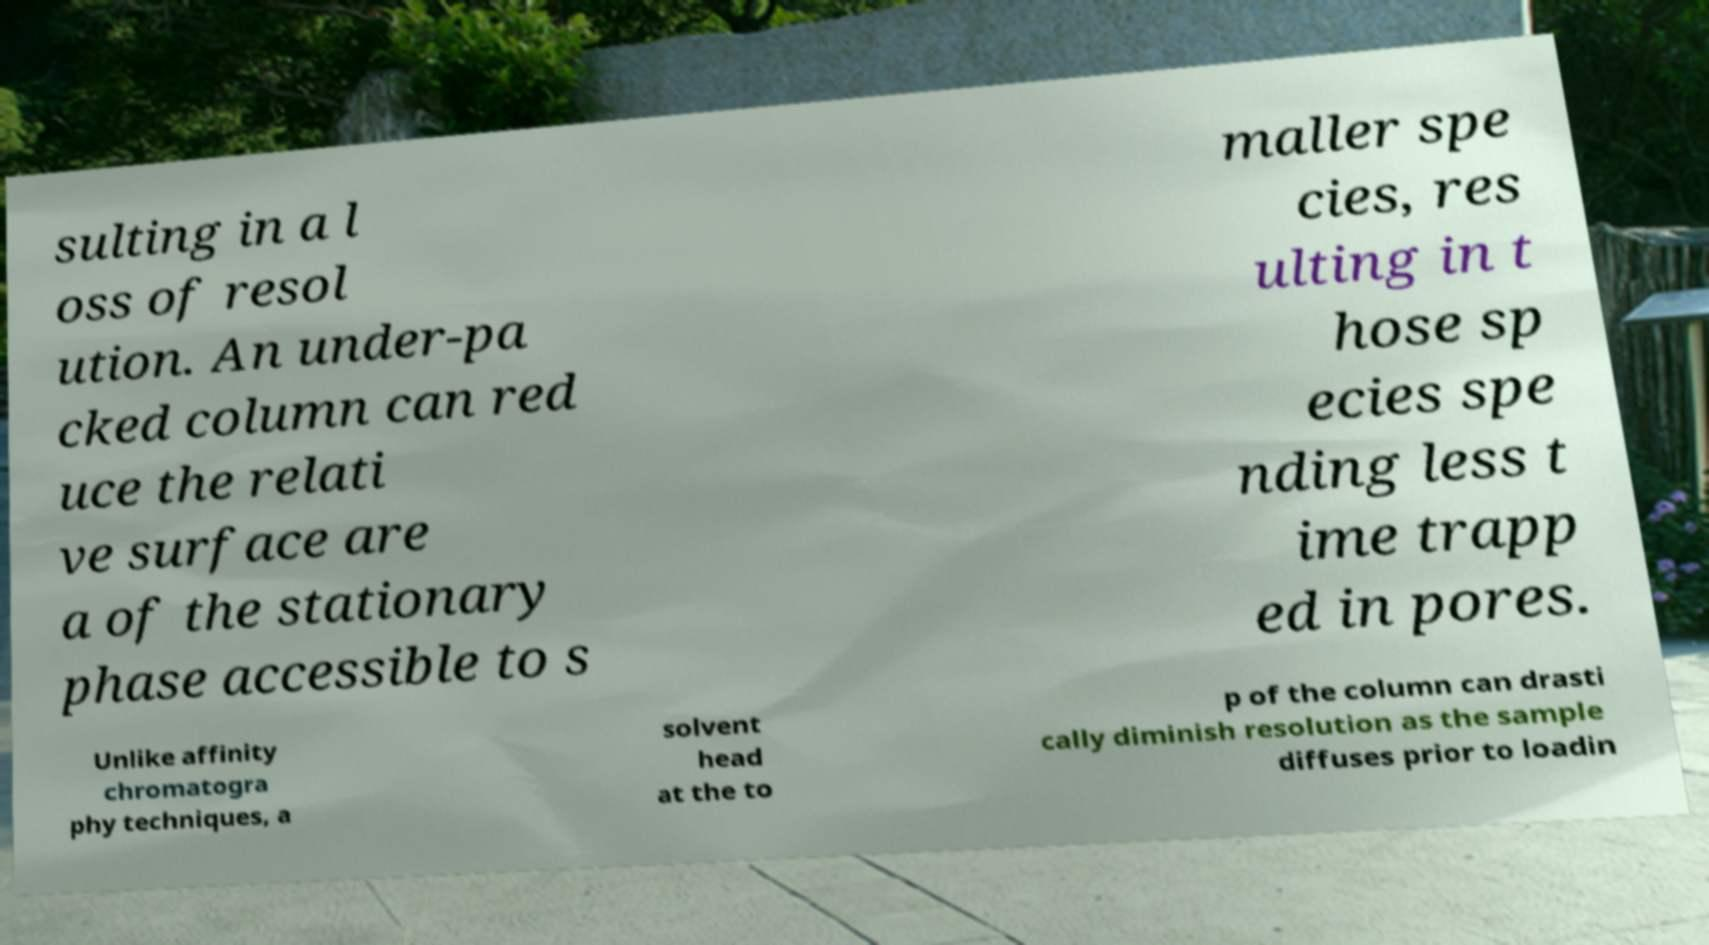I need the written content from this picture converted into text. Can you do that? sulting in a l oss of resol ution. An under-pa cked column can red uce the relati ve surface are a of the stationary phase accessible to s maller spe cies, res ulting in t hose sp ecies spe nding less t ime trapp ed in pores. Unlike affinity chromatogra phy techniques, a solvent head at the to p of the column can drasti cally diminish resolution as the sample diffuses prior to loadin 